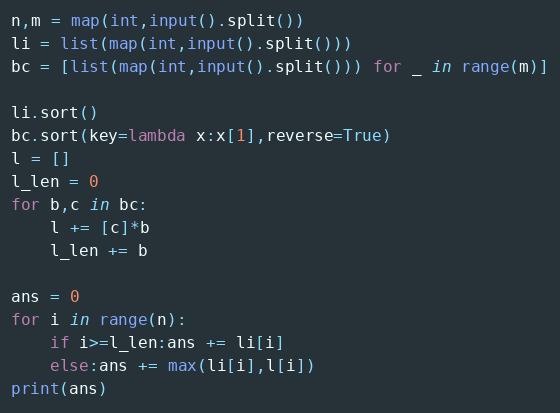<code> <loc_0><loc_0><loc_500><loc_500><_Python_>n,m = map(int,input().split())
li = list(map(int,input().split()))
bc = [list(map(int,input().split())) for _ in range(m)]

li.sort()
bc.sort(key=lambda x:x[1],reverse=True)
l = []
l_len = 0
for b,c in bc:
    l += [c]*b
    l_len += b
    
ans = 0
for i in range(n):
    if i>=l_len:ans += li[i]
    else:ans += max(li[i],l[i])
print(ans)</code> 